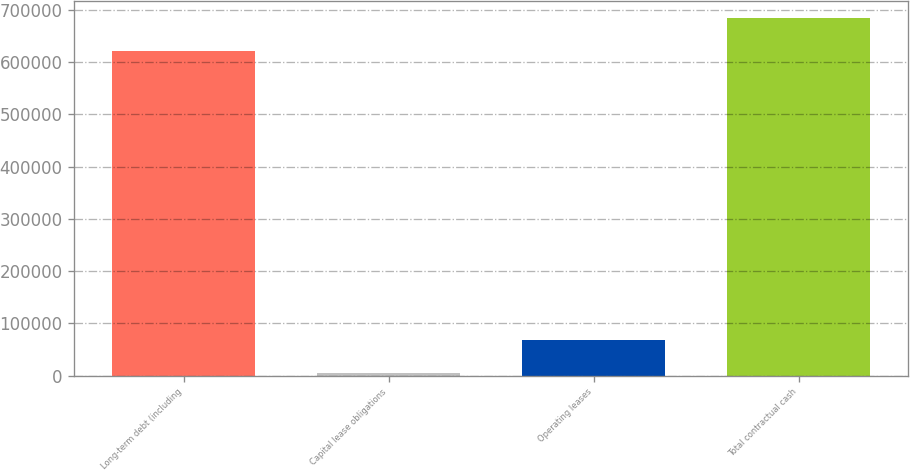<chart> <loc_0><loc_0><loc_500><loc_500><bar_chart><fcel>Long-term debt (including<fcel>Capital lease obligations<fcel>Operating leases<fcel>Total contractual cash<nl><fcel>620622<fcel>5628<fcel>68449<fcel>683443<nl></chart> 